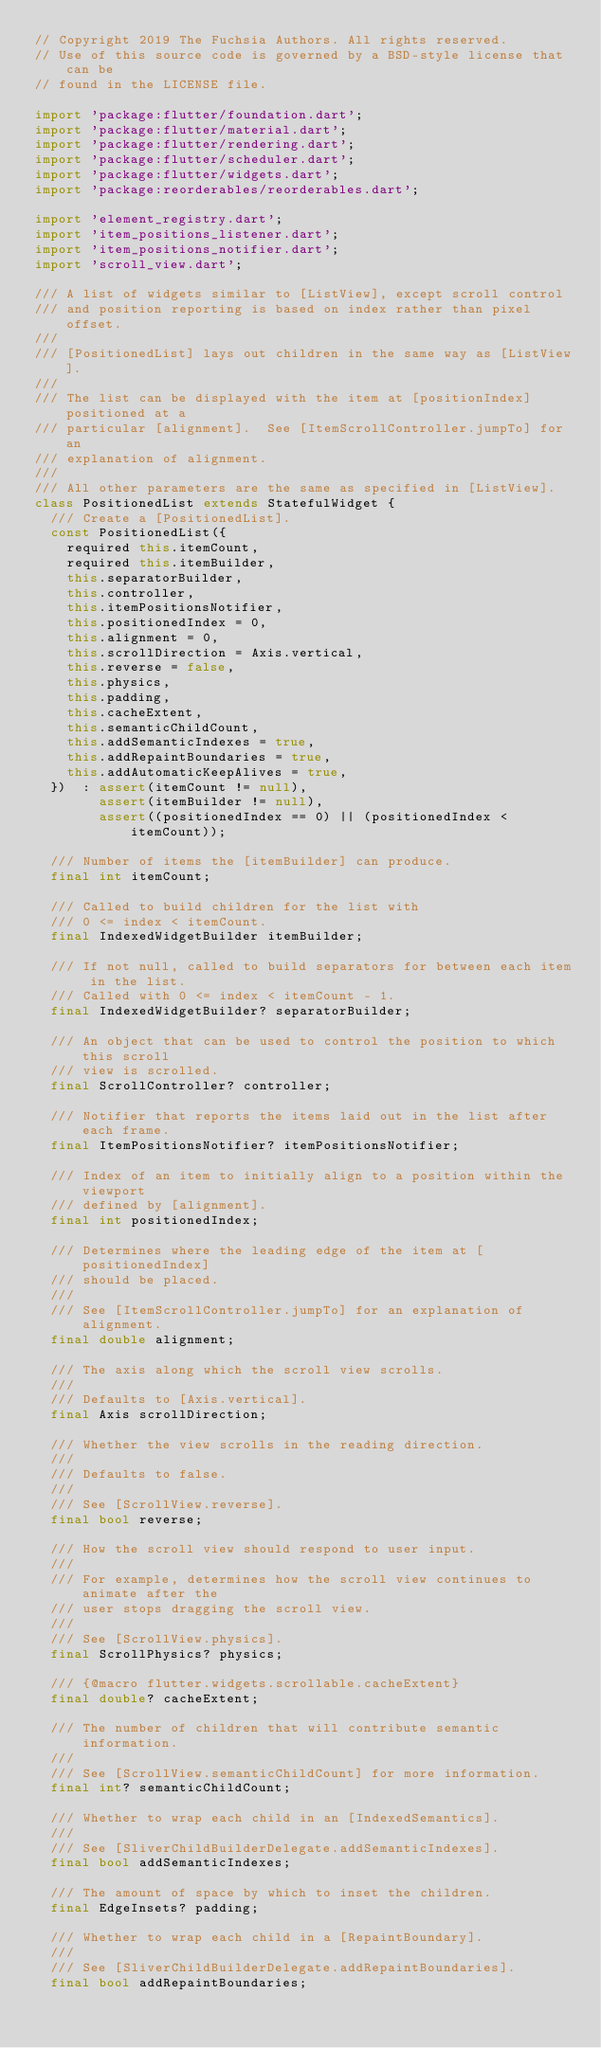<code> <loc_0><loc_0><loc_500><loc_500><_Dart_>// Copyright 2019 The Fuchsia Authors. All rights reserved.
// Use of this source code is governed by a BSD-style license that can be
// found in the LICENSE file.

import 'package:flutter/foundation.dart';
import 'package:flutter/material.dart';
import 'package:flutter/rendering.dart';
import 'package:flutter/scheduler.dart';
import 'package:flutter/widgets.dart';
import 'package:reorderables/reorderables.dart';

import 'element_registry.dart';
import 'item_positions_listener.dart';
import 'item_positions_notifier.dart';
import 'scroll_view.dart';

/// A list of widgets similar to [ListView], except scroll control
/// and position reporting is based on index rather than pixel offset.
///
/// [PositionedList] lays out children in the same way as [ListView].
///
/// The list can be displayed with the item at [positionIndex] positioned at a
/// particular [alignment].  See [ItemScrollController.jumpTo] for an
/// explanation of alignment.
///
/// All other parameters are the same as specified in [ListView].
class PositionedList extends StatefulWidget {
  /// Create a [PositionedList].
  const PositionedList({
    required this.itemCount,
    required this.itemBuilder,
    this.separatorBuilder,
    this.controller,
    this.itemPositionsNotifier,
    this.positionedIndex = 0,
    this.alignment = 0,
    this.scrollDirection = Axis.vertical,
    this.reverse = false,
    this.physics,
    this.padding,
    this.cacheExtent,
    this.semanticChildCount,
    this.addSemanticIndexes = true,
    this.addRepaintBoundaries = true,
    this.addAutomaticKeepAlives = true,
  })  : assert(itemCount != null),
        assert(itemBuilder != null),
        assert((positionedIndex == 0) || (positionedIndex < itemCount));

  /// Number of items the [itemBuilder] can produce.
  final int itemCount;

  /// Called to build children for the list with
  /// 0 <= index < itemCount.
  final IndexedWidgetBuilder itemBuilder;

  /// If not null, called to build separators for between each item in the list.
  /// Called with 0 <= index < itemCount - 1.
  final IndexedWidgetBuilder? separatorBuilder;

  /// An object that can be used to control the position to which this scroll
  /// view is scrolled.
  final ScrollController? controller;

  /// Notifier that reports the items laid out in the list after each frame.
  final ItemPositionsNotifier? itemPositionsNotifier;

  /// Index of an item to initially align to a position within the viewport
  /// defined by [alignment].
  final int positionedIndex;

  /// Determines where the leading edge of the item at [positionedIndex]
  /// should be placed.
  ///
  /// See [ItemScrollController.jumpTo] for an explanation of alignment.
  final double alignment;

  /// The axis along which the scroll view scrolls.
  ///
  /// Defaults to [Axis.vertical].
  final Axis scrollDirection;

  /// Whether the view scrolls in the reading direction.
  ///
  /// Defaults to false.
  ///
  /// See [ScrollView.reverse].
  final bool reverse;

  /// How the scroll view should respond to user input.
  ///
  /// For example, determines how the scroll view continues to animate after the
  /// user stops dragging the scroll view.
  ///
  /// See [ScrollView.physics].
  final ScrollPhysics? physics;

  /// {@macro flutter.widgets.scrollable.cacheExtent}
  final double? cacheExtent;

  /// The number of children that will contribute semantic information.
  ///
  /// See [ScrollView.semanticChildCount] for more information.
  final int? semanticChildCount;

  /// Whether to wrap each child in an [IndexedSemantics].
  ///
  /// See [SliverChildBuilderDelegate.addSemanticIndexes].
  final bool addSemanticIndexes;

  /// The amount of space by which to inset the children.
  final EdgeInsets? padding;

  /// Whether to wrap each child in a [RepaintBoundary].
  ///
  /// See [SliverChildBuilderDelegate.addRepaintBoundaries].
  final bool addRepaintBoundaries;
</code> 